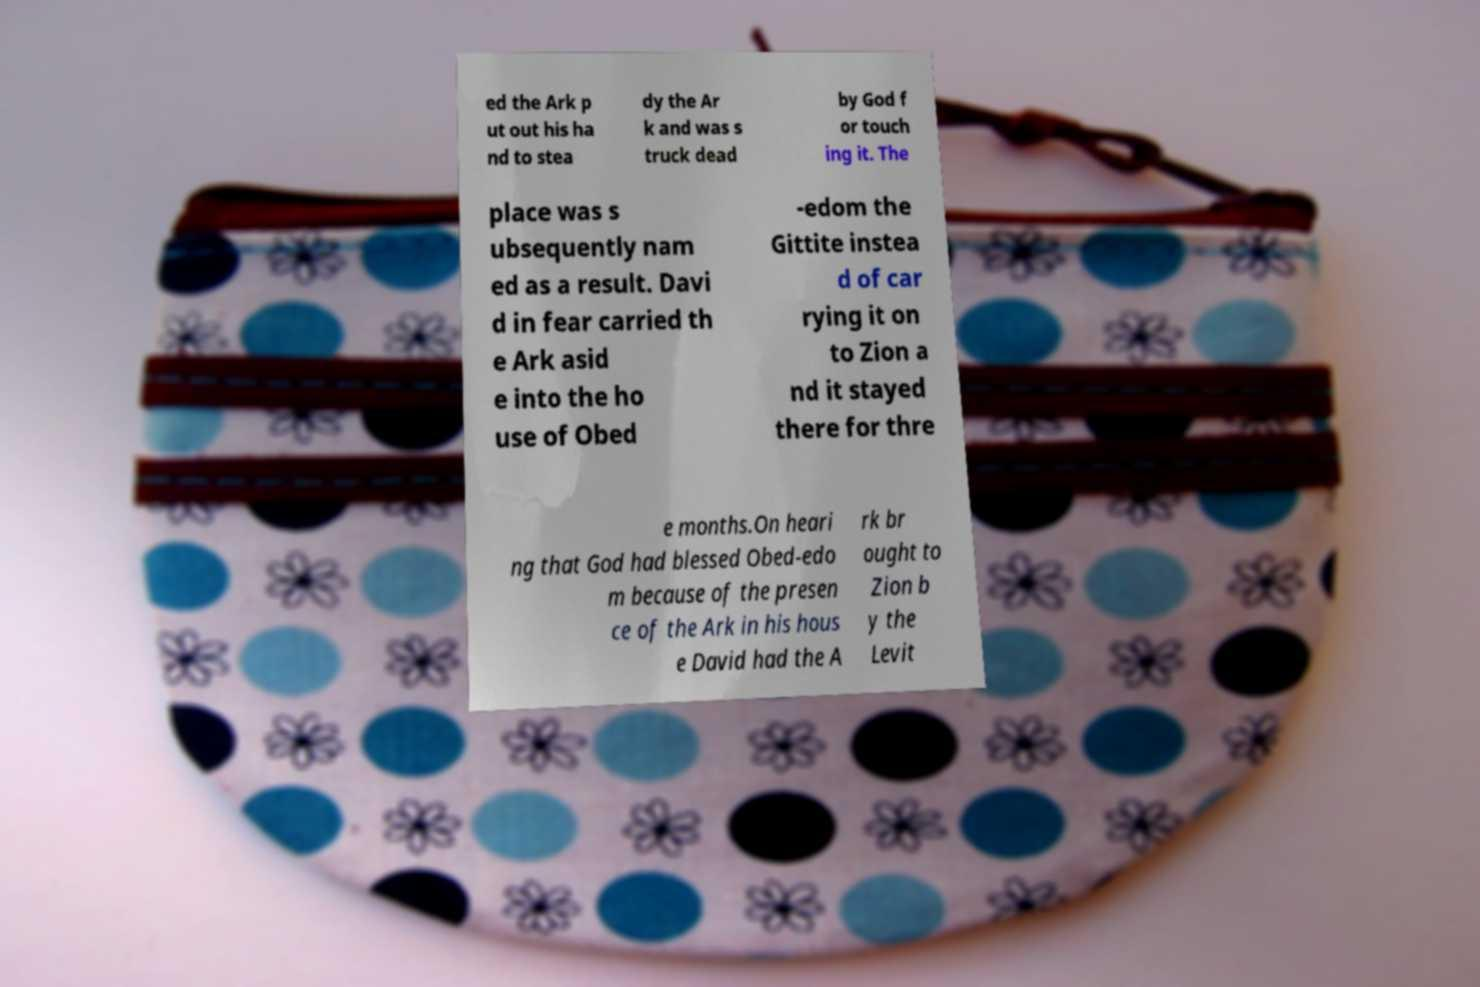Please read and relay the text visible in this image. What does it say? ed the Ark p ut out his ha nd to stea dy the Ar k and was s truck dead by God f or touch ing it. The place was s ubsequently nam ed as a result. Davi d in fear carried th e Ark asid e into the ho use of Obed -edom the Gittite instea d of car rying it on to Zion a nd it stayed there for thre e months.On heari ng that God had blessed Obed-edo m because of the presen ce of the Ark in his hous e David had the A rk br ought to Zion b y the Levit 